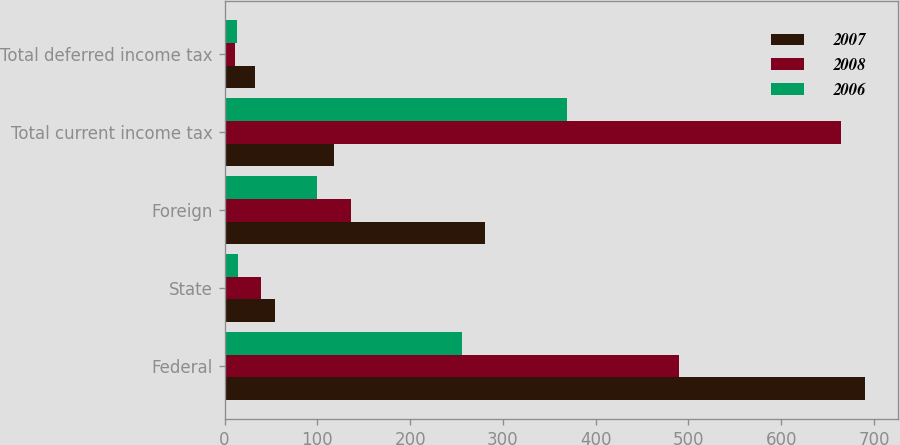<chart> <loc_0><loc_0><loc_500><loc_500><stacked_bar_chart><ecel><fcel>Federal<fcel>State<fcel>Foreign<fcel>Total current income tax<fcel>Total deferred income tax<nl><fcel>2007<fcel>690.9<fcel>54.7<fcel>280.3<fcel>117.65<fcel>33.1<nl><fcel>2008<fcel>490.2<fcel>38.8<fcel>136<fcel>665<fcel>10.8<nl><fcel>2006<fcel>255.8<fcel>14.4<fcel>99.3<fcel>369.5<fcel>13.8<nl></chart> 